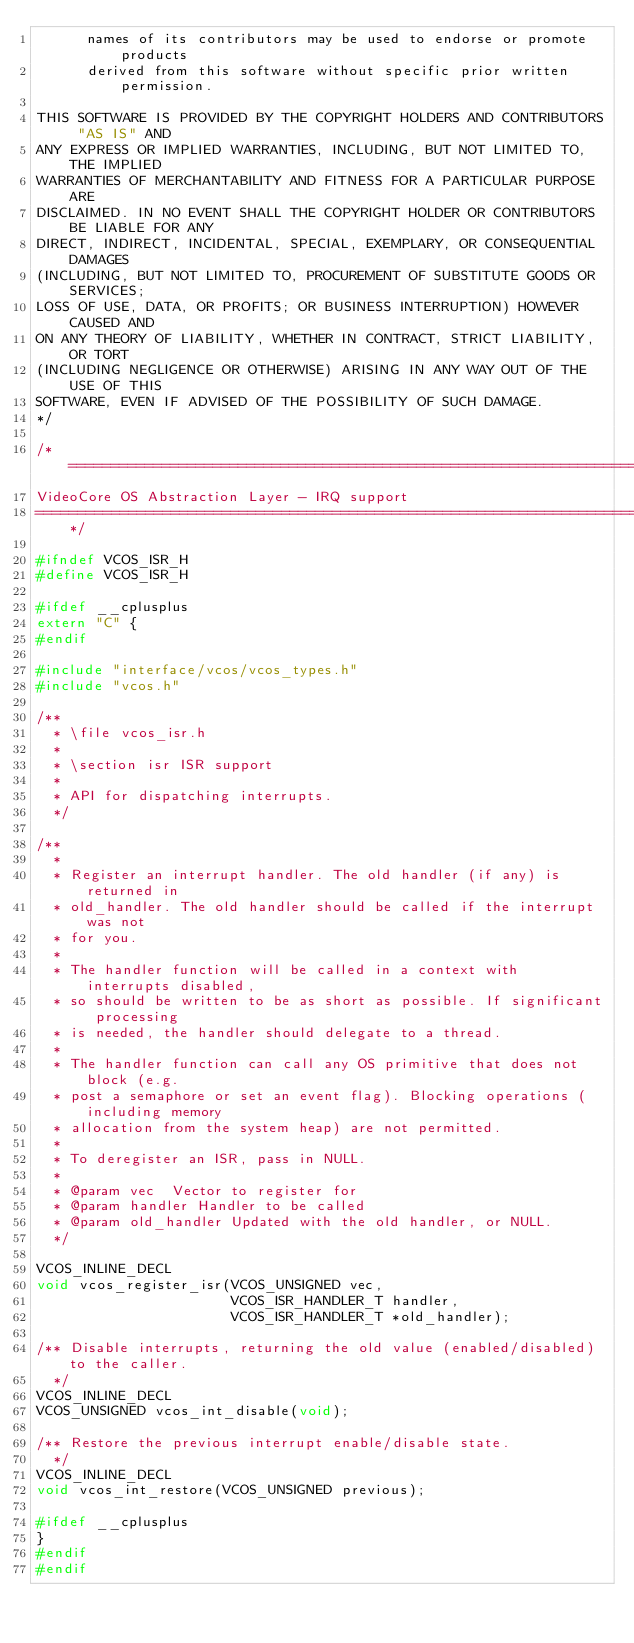Convert code to text. <code><loc_0><loc_0><loc_500><loc_500><_C_>      names of its contributors may be used to endorse or promote products
      derived from this software without specific prior written permission.

THIS SOFTWARE IS PROVIDED BY THE COPYRIGHT HOLDERS AND CONTRIBUTORS "AS IS" AND
ANY EXPRESS OR IMPLIED WARRANTIES, INCLUDING, BUT NOT LIMITED TO, THE IMPLIED
WARRANTIES OF MERCHANTABILITY AND FITNESS FOR A PARTICULAR PURPOSE ARE
DISCLAIMED. IN NO EVENT SHALL THE COPYRIGHT HOLDER OR CONTRIBUTORS BE LIABLE FOR ANY
DIRECT, INDIRECT, INCIDENTAL, SPECIAL, EXEMPLARY, OR CONSEQUENTIAL DAMAGES
(INCLUDING, BUT NOT LIMITED TO, PROCUREMENT OF SUBSTITUTE GOODS OR SERVICES;
LOSS OF USE, DATA, OR PROFITS; OR BUSINESS INTERRUPTION) HOWEVER CAUSED AND
ON ANY THEORY OF LIABILITY, WHETHER IN CONTRACT, STRICT LIABILITY, OR TORT
(INCLUDING NEGLIGENCE OR OTHERWISE) ARISING IN ANY WAY OUT OF THE USE OF THIS
SOFTWARE, EVEN IF ADVISED OF THE POSSIBILITY OF SUCH DAMAGE.
*/

/*=============================================================================
VideoCore OS Abstraction Layer - IRQ support
=============================================================================*/

#ifndef VCOS_ISR_H
#define VCOS_ISR_H

#ifdef __cplusplus
extern "C" {
#endif

#include "interface/vcos/vcos_types.h"
#include "vcos.h"

/**
  * \file vcos_isr.h
  *
  * \section isr ISR support
  *
  * API for dispatching interrupts.
  */

/**
  *
  * Register an interrupt handler. The old handler (if any) is returned in
  * old_handler. The old handler should be called if the interrupt was not
  * for you.
  *
  * The handler function will be called in a context with interrupts disabled,
  * so should be written to be as short as possible. If significant processing
  * is needed, the handler should delegate to a thread.
  *
  * The handler function can call any OS primitive that does not block (e.g.
  * post a semaphore or set an event flag). Blocking operations (including memory
  * allocation from the system heap) are not permitted.
  *
  * To deregister an ISR, pass in NULL.
  *
  * @param vec  Vector to register for
  * @param handler Handler to be called
  * @param old_handler Updated with the old handler, or NULL.
  */

VCOS_INLINE_DECL
void vcos_register_isr(VCOS_UNSIGNED vec,
                       VCOS_ISR_HANDLER_T handler,
                       VCOS_ISR_HANDLER_T *old_handler);

/** Disable interrupts, returning the old value (enabled/disabled) to the caller.
  */
VCOS_INLINE_DECL
VCOS_UNSIGNED vcos_int_disable(void);

/** Restore the previous interrupt enable/disable state.
  */
VCOS_INLINE_DECL
void vcos_int_restore(VCOS_UNSIGNED previous);

#ifdef __cplusplus
}
#endif
#endif

</code> 